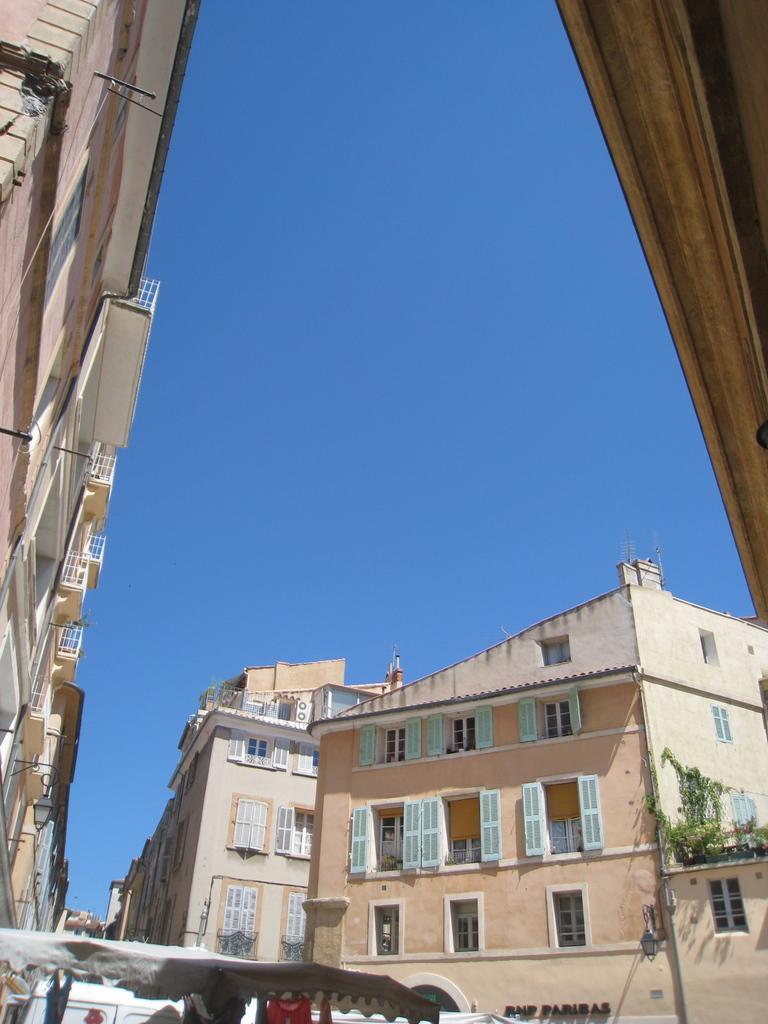Describe this image in one or two sentences. In this image we can see buildings with windows and railings. In the foreground of the image we can see a tent and clothes. On the right side of the image we can see lump on the wall and some plants. At the top of the image we can see the sky. 